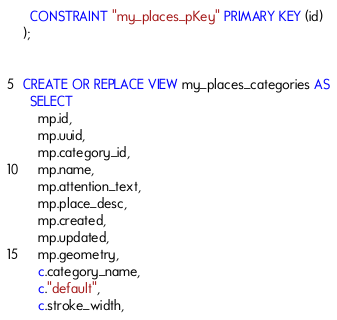<code> <loc_0><loc_0><loc_500><loc_500><_SQL_>  CONSTRAINT "my_places_pKey" PRIMARY KEY (id)
);


CREATE OR REPLACE VIEW my_places_categories AS
  SELECT
    mp.id,
    mp.uuid,
    mp.category_id,
    mp.name,
    mp.attention_text,
    mp.place_desc,
    mp.created,
    mp.updated,
    mp.geometry,
    c.category_name,
    c."default",
    c.stroke_width,</code> 